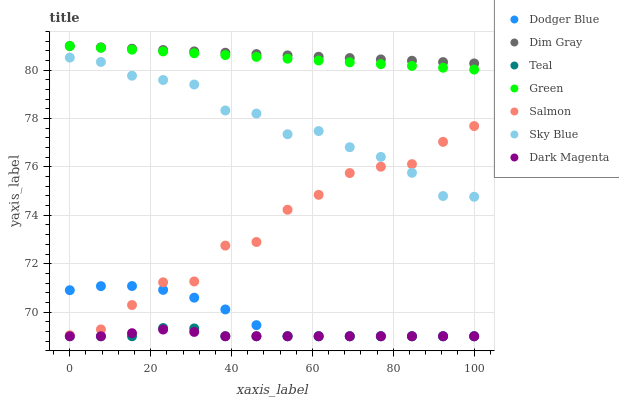Does Dark Magenta have the minimum area under the curve?
Answer yes or no. Yes. Does Dim Gray have the maximum area under the curve?
Answer yes or no. Yes. Does Salmon have the minimum area under the curve?
Answer yes or no. No. Does Salmon have the maximum area under the curve?
Answer yes or no. No. Is Green the smoothest?
Answer yes or no. Yes. Is Salmon the roughest?
Answer yes or no. Yes. Is Dark Magenta the smoothest?
Answer yes or no. No. Is Dark Magenta the roughest?
Answer yes or no. No. Does Dark Magenta have the lowest value?
Answer yes or no. Yes. Does Salmon have the lowest value?
Answer yes or no. No. Does Green have the highest value?
Answer yes or no. Yes. Does Salmon have the highest value?
Answer yes or no. No. Is Dark Magenta less than Green?
Answer yes or no. Yes. Is Dim Gray greater than Teal?
Answer yes or no. Yes. Does Dim Gray intersect Green?
Answer yes or no. Yes. Is Dim Gray less than Green?
Answer yes or no. No. Is Dim Gray greater than Green?
Answer yes or no. No. Does Dark Magenta intersect Green?
Answer yes or no. No. 